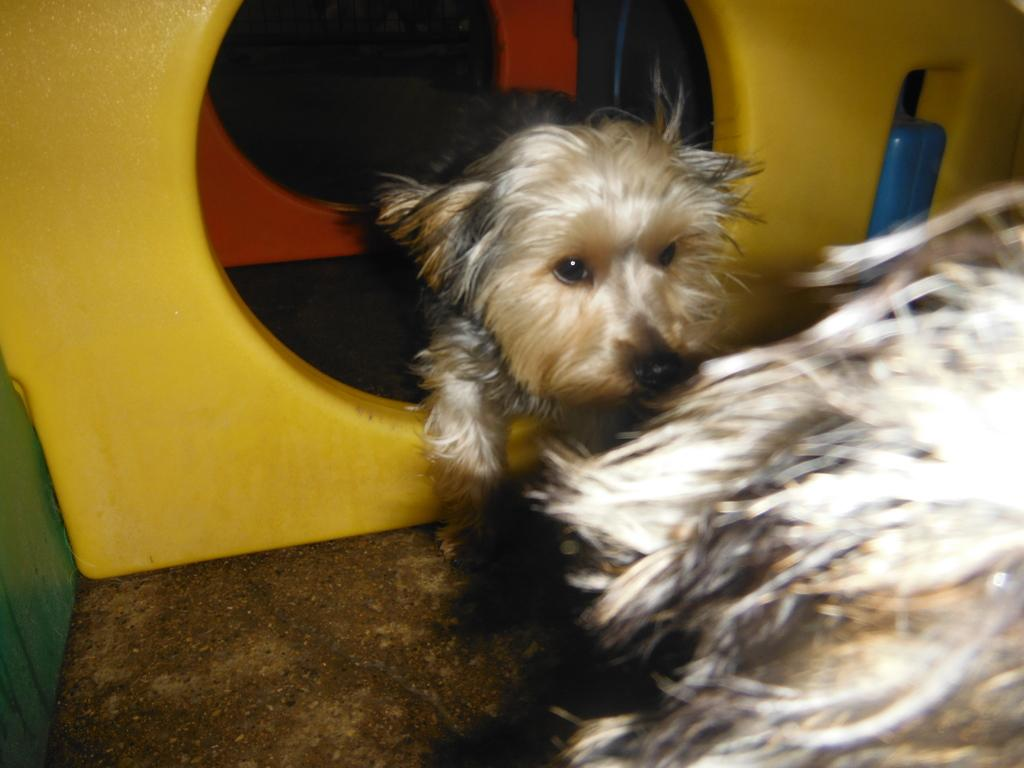What type of animal is present in the image? There is a dog in the picture. Can you describe any structures associated with the dog in the image? There appears to be a dog house in the picture. What type of dolls can be seen playing with jelly in the image? There are no dolls or jelly present in the image; it features a dog and a dog house. 